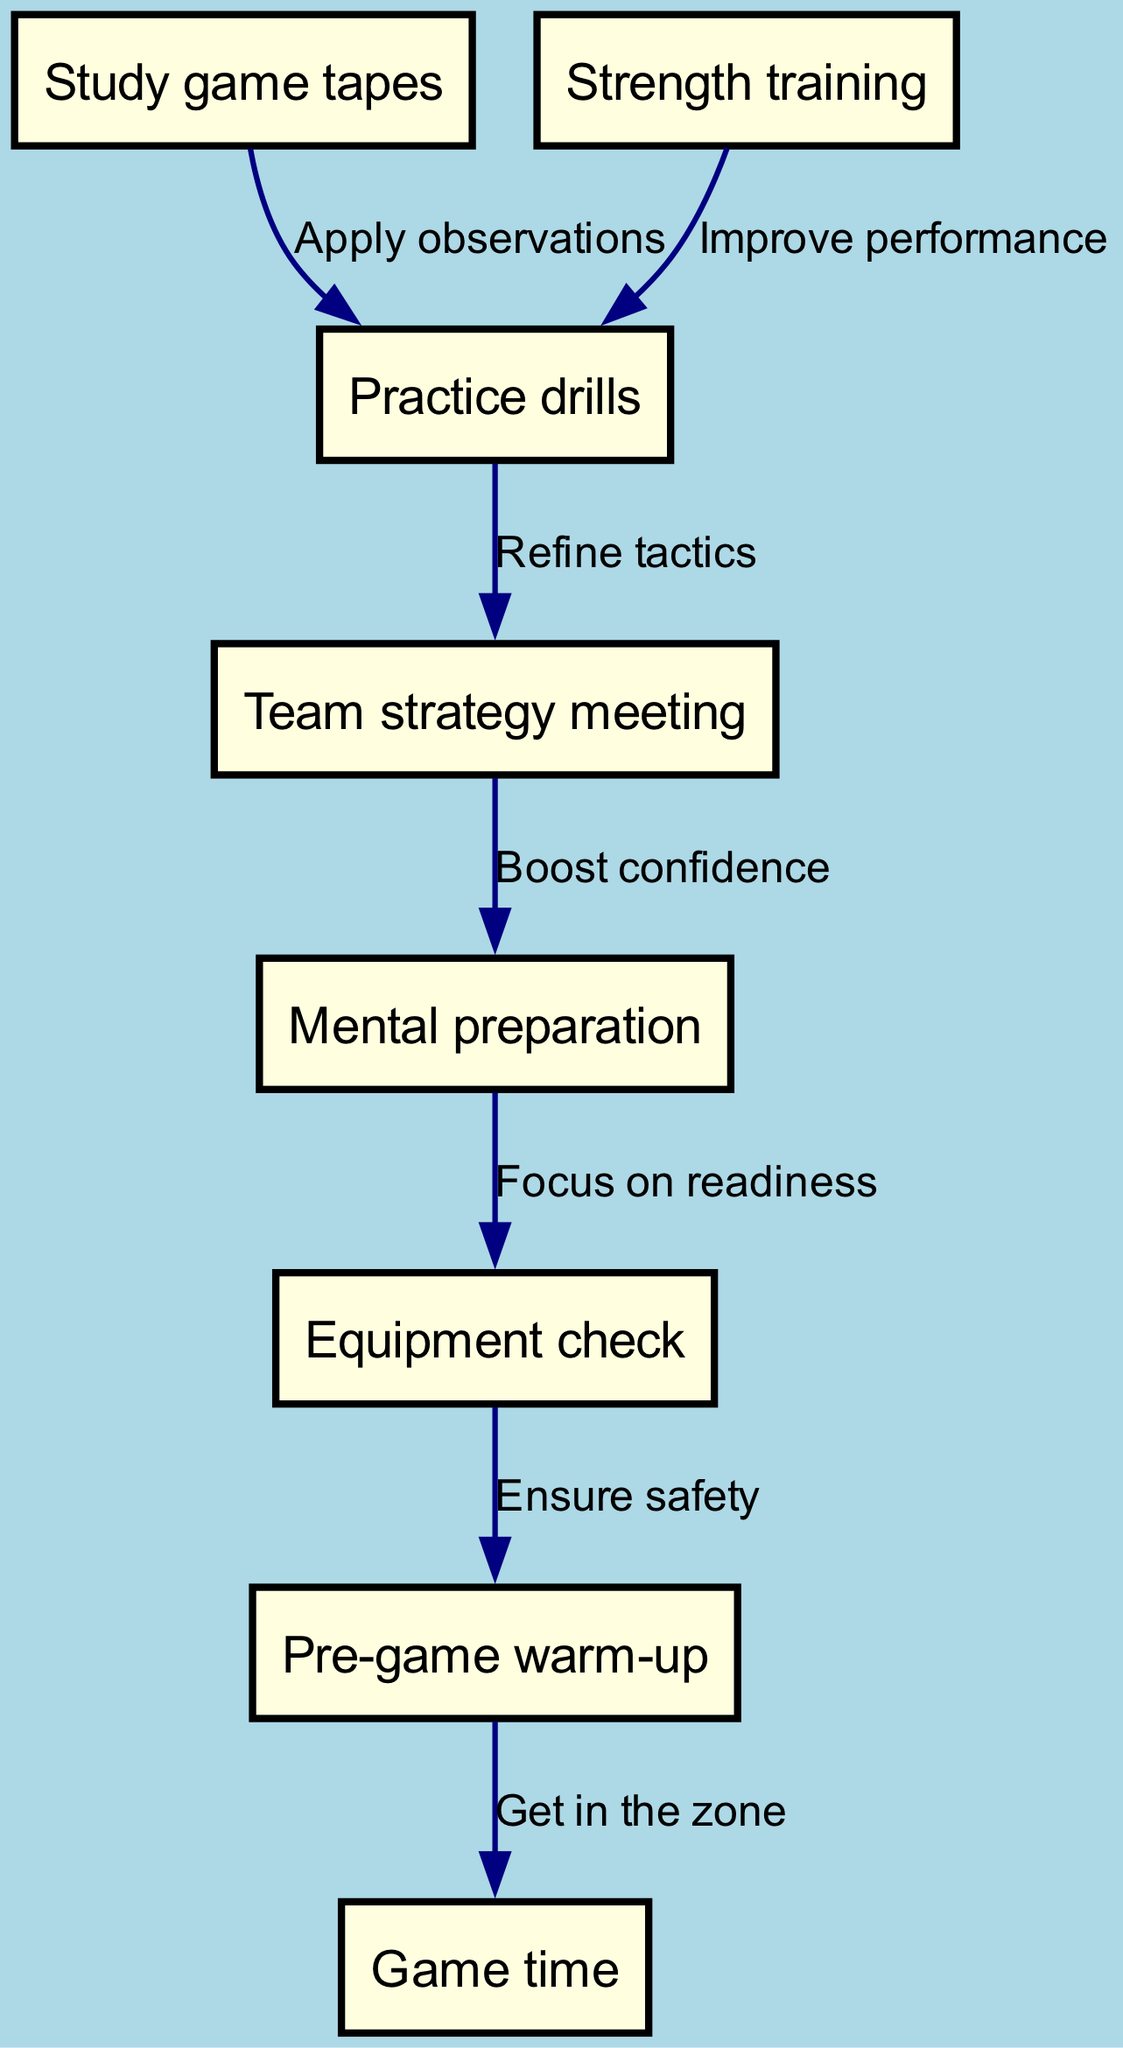What is the first step in preparing for a big football game? The first step indicated in the diagram is "Study game tapes," which is the starting node in the flowchart.
Answer: Study game tapes How many nodes are present in the flowchart? By counting the distinct activities or steps represented in the nodes section of the diagram, we find there are a total of 8 nodes.
Answer: 8 What comes after "Strength training"? "Practice drills" comes after "Strength training," as indicated by the directed edge in the flowchart that connects these two nodes.
Answer: Practice drills What is the purpose of the "Team strategy meeting"? The "Team strategy meeting" is connected to "Mental preparation" with the edge labeled "Boost confidence," indicating its purpose is to enhance players' confidence before the game.
Answer: Boost confidence What is the last step before "Game time"? The last step before reaching "Game time" is the "Pre-game warm-up," which is the penultimate node directed to the final node in the flowchart.
Answer: Pre-game warm-up What connects "Study game tapes" to "Practice drills"? The edge labeled "Apply observations" connects "Study game tapes" to "Practice drills," indicating the action taken after studying the tapes.
Answer: Apply observations What are the two activities that lead directly into "Practice drills"? "Strength training" and "Study game tapes" both feed into "Practice drills," as they are the two nodes from which edges point to it.
Answer: Strength training, Study game tapes How does "Mental preparation" relate to "Equipment check"? "Mental preparation" is connected to "Equipment check" with the edge labeled "Focus on readiness," showing that mental prep is intended to ensure players are ready, affecting their equipment check.
Answer: Focus on readiness 